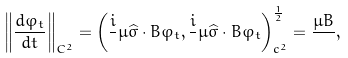<formula> <loc_0><loc_0><loc_500><loc_500>\left \| \frac { d \varphi _ { t } } { d t } \right \| _ { C ^ { 2 } } = \left ( \frac { i } { } \mu { \widehat { \sigma } } \cdot { B } \varphi _ { t } , \frac { i } { } \mu { \widehat { \sigma } } \cdot { B } \varphi _ { t } \right ) ^ { \frac { 1 } { 2 } } _ { c ^ { 2 } } = \frac { \mu B } { } ,</formula> 